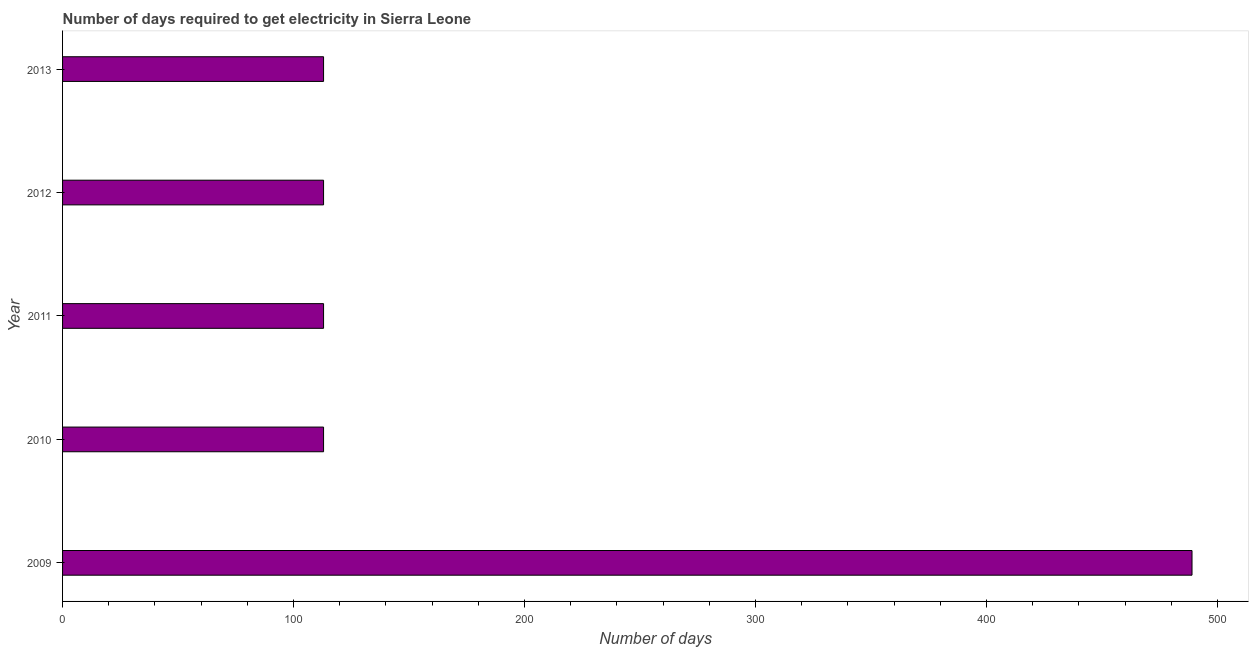What is the title of the graph?
Make the answer very short. Number of days required to get electricity in Sierra Leone. What is the label or title of the X-axis?
Your response must be concise. Number of days. What is the label or title of the Y-axis?
Your answer should be very brief. Year. What is the time to get electricity in 2011?
Ensure brevity in your answer.  113. Across all years, what is the maximum time to get electricity?
Offer a very short reply. 489. Across all years, what is the minimum time to get electricity?
Make the answer very short. 113. In which year was the time to get electricity minimum?
Your response must be concise. 2010. What is the sum of the time to get electricity?
Give a very brief answer. 941. What is the difference between the time to get electricity in 2009 and 2013?
Your answer should be very brief. 376. What is the average time to get electricity per year?
Offer a terse response. 188. What is the median time to get electricity?
Make the answer very short. 113. In how many years, is the time to get electricity greater than 420 ?
Your response must be concise. 1. What is the difference between the highest and the second highest time to get electricity?
Offer a very short reply. 376. Is the sum of the time to get electricity in 2010 and 2011 greater than the maximum time to get electricity across all years?
Provide a succinct answer. No. What is the difference between the highest and the lowest time to get electricity?
Provide a short and direct response. 376. How many bars are there?
Make the answer very short. 5. Are all the bars in the graph horizontal?
Ensure brevity in your answer.  Yes. What is the difference between two consecutive major ticks on the X-axis?
Provide a succinct answer. 100. What is the Number of days of 2009?
Your response must be concise. 489. What is the Number of days in 2010?
Your answer should be compact. 113. What is the Number of days in 2011?
Give a very brief answer. 113. What is the Number of days of 2012?
Provide a short and direct response. 113. What is the Number of days in 2013?
Give a very brief answer. 113. What is the difference between the Number of days in 2009 and 2010?
Offer a terse response. 376. What is the difference between the Number of days in 2009 and 2011?
Your answer should be very brief. 376. What is the difference between the Number of days in 2009 and 2012?
Ensure brevity in your answer.  376. What is the difference between the Number of days in 2009 and 2013?
Your answer should be very brief. 376. What is the difference between the Number of days in 2010 and 2011?
Your response must be concise. 0. What is the difference between the Number of days in 2011 and 2012?
Provide a short and direct response. 0. What is the difference between the Number of days in 2011 and 2013?
Your answer should be compact. 0. What is the difference between the Number of days in 2012 and 2013?
Offer a very short reply. 0. What is the ratio of the Number of days in 2009 to that in 2010?
Your answer should be very brief. 4.33. What is the ratio of the Number of days in 2009 to that in 2011?
Offer a terse response. 4.33. What is the ratio of the Number of days in 2009 to that in 2012?
Provide a short and direct response. 4.33. What is the ratio of the Number of days in 2009 to that in 2013?
Keep it short and to the point. 4.33. What is the ratio of the Number of days in 2010 to that in 2013?
Ensure brevity in your answer.  1. What is the ratio of the Number of days in 2011 to that in 2012?
Ensure brevity in your answer.  1. What is the ratio of the Number of days in 2011 to that in 2013?
Provide a short and direct response. 1. 